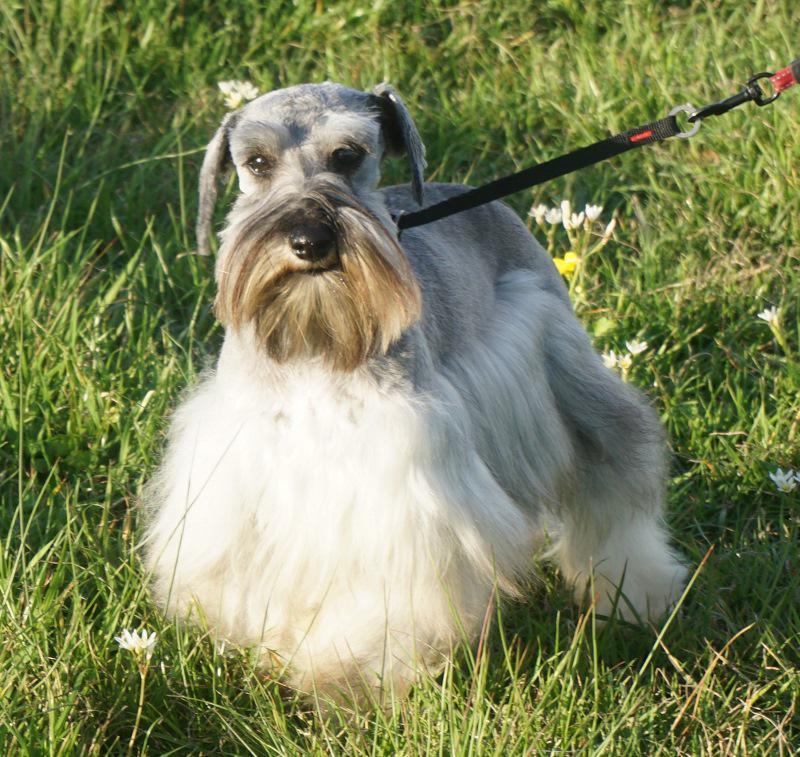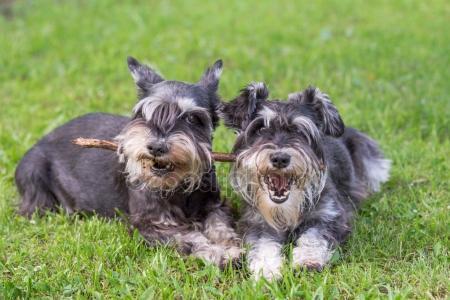The first image is the image on the left, the second image is the image on the right. Assess this claim about the two images: "a dog is standing in the grass with a taught leash". Correct or not? Answer yes or no. Yes. The first image is the image on the left, the second image is the image on the right. Examine the images to the left and right. Is the description "A long haired light colored dog is standing outside in the grass on a leash." accurate? Answer yes or no. Yes. 